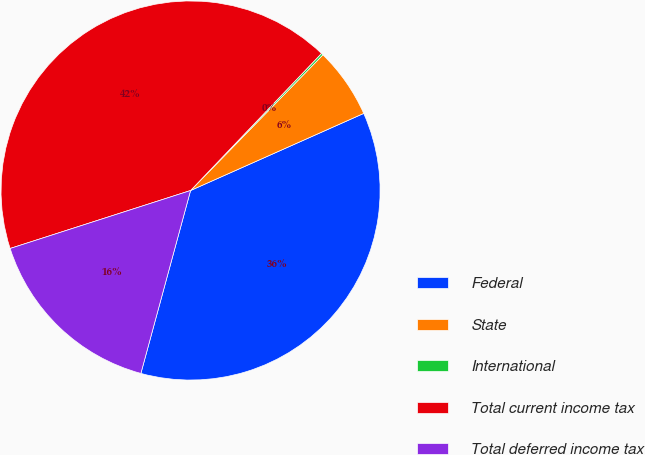Convert chart. <chart><loc_0><loc_0><loc_500><loc_500><pie_chart><fcel>Federal<fcel>State<fcel>International<fcel>Total current income tax<fcel>Total deferred income tax<nl><fcel>35.89%<fcel>6.03%<fcel>0.17%<fcel>42.08%<fcel>15.83%<nl></chart> 